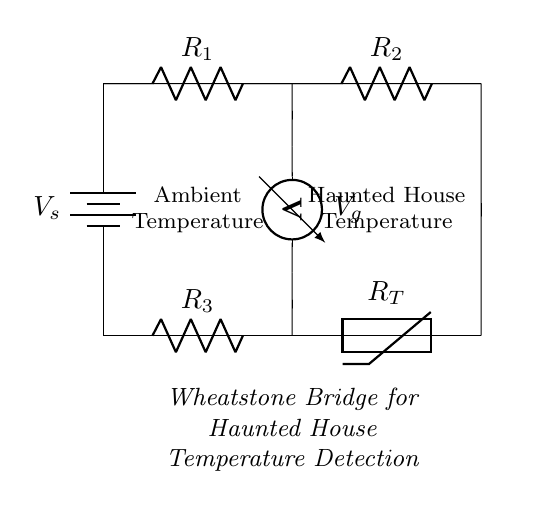What type of circuit is represented here? This is a Wheatstone bridge circuit, which is primarily used to measure resistance and can detect small changes in resistance due to temperature changes.
Answer: Wheatstone bridge What is the role of the thermistor in this circuit? The thermistor serves as a temperature-sensitive resistor, changing its resistance based on the ambient temperature, allowing the bridge to detect subtle temperature changes.
Answer: Temperature sensor How many resistors are present in the circuit? There are three resistors indicated in the circuit diagram: R1, R2, and R3.
Answer: Three What is the purpose of the voltmeter in the circuit? The voltmeter measures the voltage difference (Vg) between the two nodes of the bridge, which indicates the imbalance caused by temperature changes affecting the resistance of the thermistor.
Answer: Measure voltage What happens to the bridge if the temperature in the haunted house increases? If the temperature increases, the resistance of the thermistor (RT) decreases, which would unbalance the bridge, resulting in a measurable voltage across the voltmeter.
Answer: Voltage increases What is the power source in the circuit? The power source in the circuit is represented by the battery labeled V_s at the left side.
Answer: Battery What do the two ambient temperature labels indicate? The labels indicate that one side of the Wheatstone bridge measures the ambient temperature (likely Room Temperature) while the other side is influenced by the temperature variations specific to the haunted house environment.
Answer: Environmental temperatures 